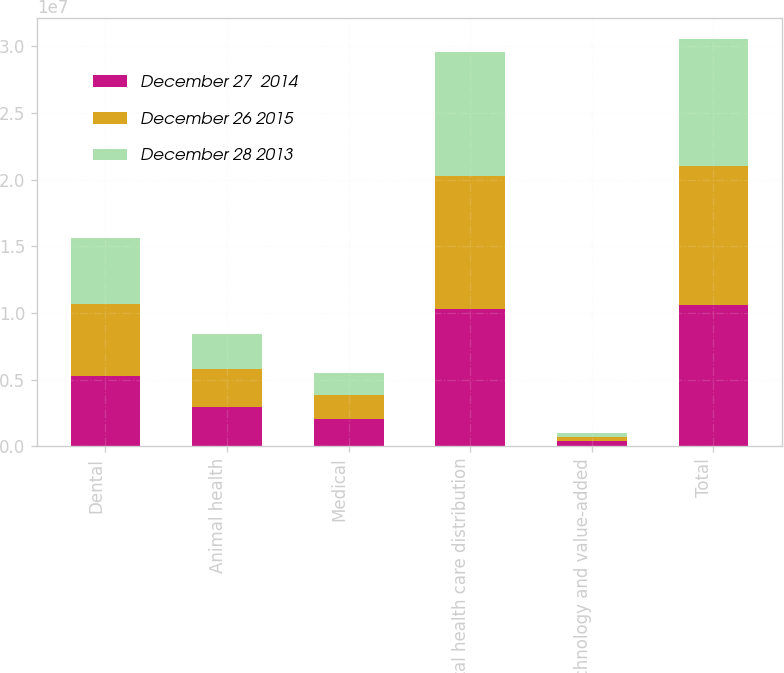Convert chart. <chart><loc_0><loc_0><loc_500><loc_500><stacked_bar_chart><ecel><fcel>Dental<fcel>Animal health<fcel>Medical<fcel>Total health care distribution<fcel>Technology and value-added<fcel>Total<nl><fcel>December 27  2014<fcel>5.27641e+06<fcel>2.92162e+06<fcel>2.07292e+06<fcel>1.02709e+07<fcel>358773<fcel>1.06297e+07<nl><fcel>December 26 2015<fcel>5.38122e+06<fcel>2.89861e+06<fcel>1.74268e+06<fcel>1.00225e+07<fcel>348878<fcel>1.03714e+07<nl><fcel>December 28 2013<fcel>4.99797e+06<fcel>2.59946e+06<fcel>1.64317e+06<fcel>9.2406e+06<fcel>320047<fcel>9.56065e+06<nl></chart> 